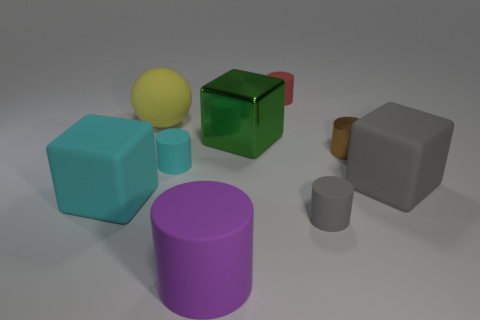Is there anything else that has the same size as the yellow rubber thing?
Provide a succinct answer. Yes. There is a tiny cylinder in front of the large block that is left of the small rubber cylinder that is to the left of the small red cylinder; what color is it?
Keep it short and to the point. Gray. What number of rubber things are in front of the tiny gray cylinder and on the right side of the gray cylinder?
Provide a succinct answer. 0. What number of cylinders are either green things or large cyan things?
Offer a terse response. 0. Is there a green metal cube?
Your response must be concise. Yes. What number of other objects are there of the same material as the yellow object?
Your answer should be very brief. 6. There is a cylinder that is the same size as the green block; what is it made of?
Ensure brevity in your answer.  Rubber. Do the shiny object that is on the left side of the tiny shiny cylinder and the brown metal thing have the same shape?
Offer a very short reply. No. Is the color of the large matte cylinder the same as the matte sphere?
Provide a succinct answer. No. How many objects are either large matte blocks right of the small red rubber cylinder or green blocks?
Keep it short and to the point. 2. 